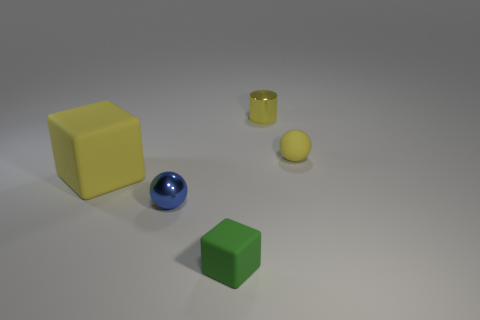Are there any big yellow cubes made of the same material as the small cube?
Give a very brief answer. Yes. There is a rubber thing that is both to the right of the blue object and behind the green object; what is its color?
Provide a short and direct response. Yellow. There is a tiny blue object that is on the left side of the green thing; what is its material?
Keep it short and to the point. Metal. Are there any other big purple matte objects of the same shape as the big rubber thing?
Your answer should be very brief. No. How many other objects are the same shape as the yellow shiny thing?
Your answer should be compact. 0. There is a tiny green object; does it have the same shape as the yellow matte object that is behind the large yellow block?
Offer a very short reply. No. What is the material of the small thing that is the same shape as the large yellow matte object?
Ensure brevity in your answer.  Rubber. How many tiny things are cylinders or rubber balls?
Your response must be concise. 2. Is the number of matte blocks that are behind the small matte ball less than the number of green rubber blocks that are on the right side of the blue metal thing?
Provide a short and direct response. Yes. What number of objects are either gray spheres or tiny yellow objects?
Your response must be concise. 2. 